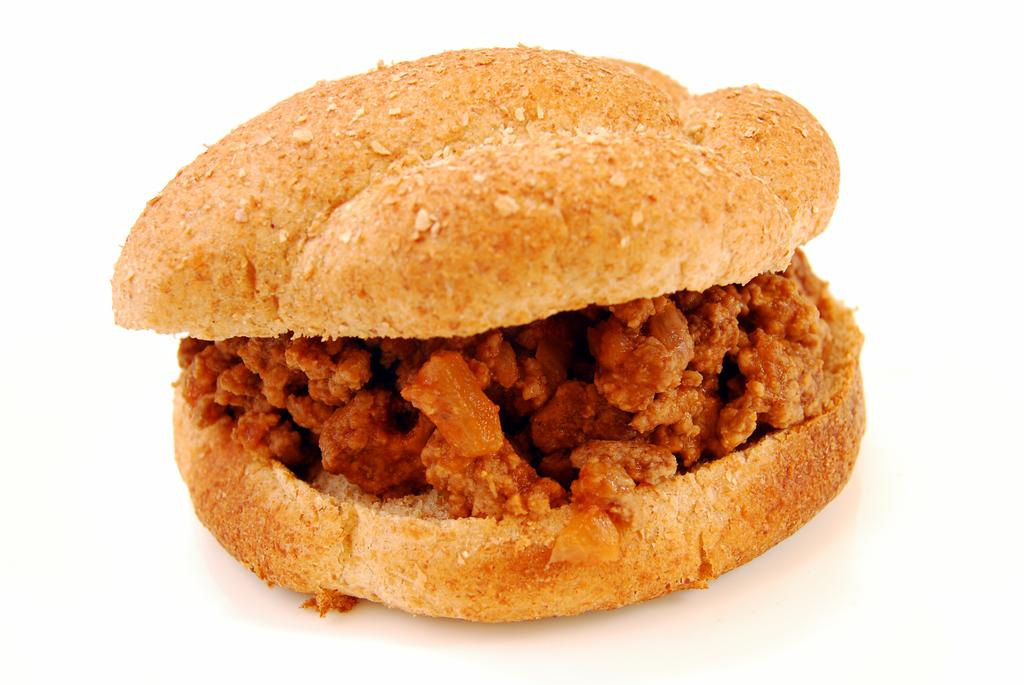What type of food is in the image? There is a burger in the image. What color is the background of the image? The background of the image is white. What type of sheet is covering the burger in the image? There is no sheet covering the burger in the image. Can you see a cart in the background of the image? There is no cart present in the image; the background is white. 